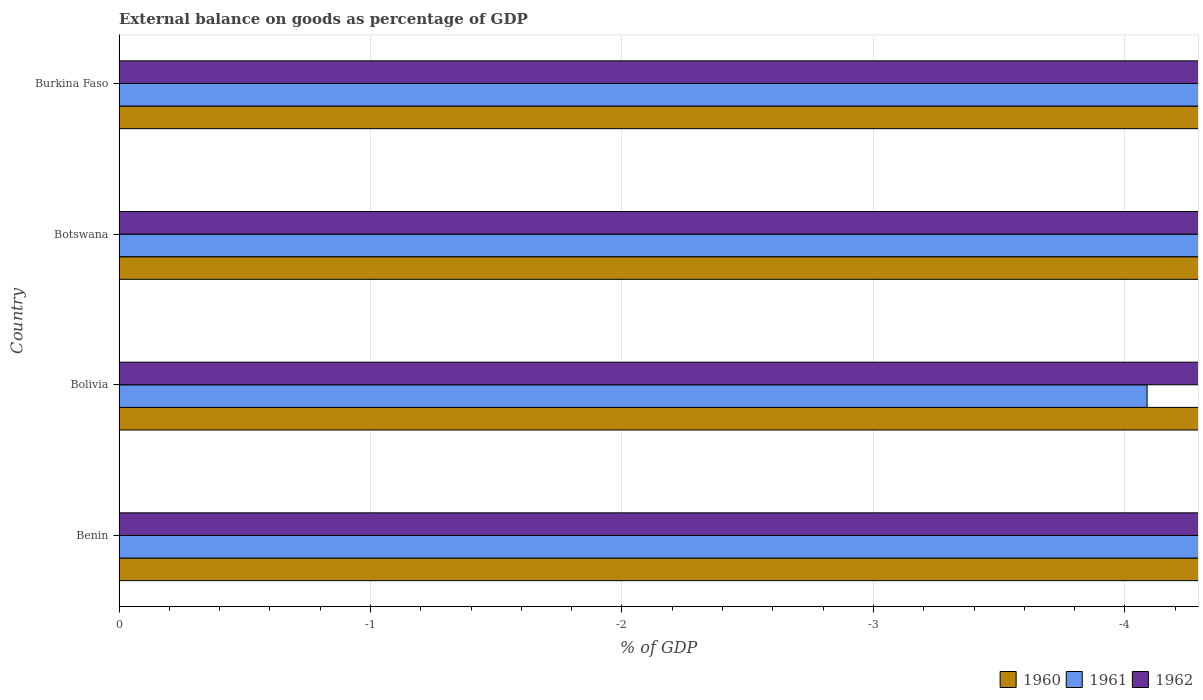How many bars are there on the 1st tick from the top?
Ensure brevity in your answer.  0. What is the label of the 2nd group of bars from the top?
Ensure brevity in your answer.  Botswana. Across all countries, what is the minimum external balance on goods as percentage of GDP in 1960?
Your answer should be very brief. 0. What is the difference between the external balance on goods as percentage of GDP in 1961 in Burkina Faso and the external balance on goods as percentage of GDP in 1962 in Bolivia?
Offer a very short reply. 0. In how many countries, is the external balance on goods as percentage of GDP in 1961 greater than the average external balance on goods as percentage of GDP in 1961 taken over all countries?
Give a very brief answer. 0. How many countries are there in the graph?
Ensure brevity in your answer.  4. What is the difference between two consecutive major ticks on the X-axis?
Your answer should be compact. 1. Are the values on the major ticks of X-axis written in scientific E-notation?
Give a very brief answer. No. Does the graph contain grids?
Ensure brevity in your answer.  Yes. How are the legend labels stacked?
Give a very brief answer. Horizontal. What is the title of the graph?
Your answer should be very brief. External balance on goods as percentage of GDP. Does "1968" appear as one of the legend labels in the graph?
Provide a short and direct response. No. What is the label or title of the X-axis?
Give a very brief answer. % of GDP. What is the % of GDP of 1960 in Benin?
Offer a very short reply. 0. What is the % of GDP in 1962 in Benin?
Give a very brief answer. 0. What is the % of GDP in 1960 in Bolivia?
Your answer should be very brief. 0. What is the % of GDP in 1961 in Bolivia?
Make the answer very short. 0. What is the % of GDP of 1962 in Bolivia?
Offer a very short reply. 0. What is the % of GDP of 1960 in Botswana?
Ensure brevity in your answer.  0. What is the % of GDP in 1961 in Botswana?
Keep it short and to the point. 0. What is the % of GDP in 1962 in Botswana?
Offer a terse response. 0. What is the % of GDP of 1961 in Burkina Faso?
Ensure brevity in your answer.  0. What is the % of GDP in 1962 in Burkina Faso?
Your response must be concise. 0. What is the total % of GDP of 1960 in the graph?
Offer a very short reply. 0. 